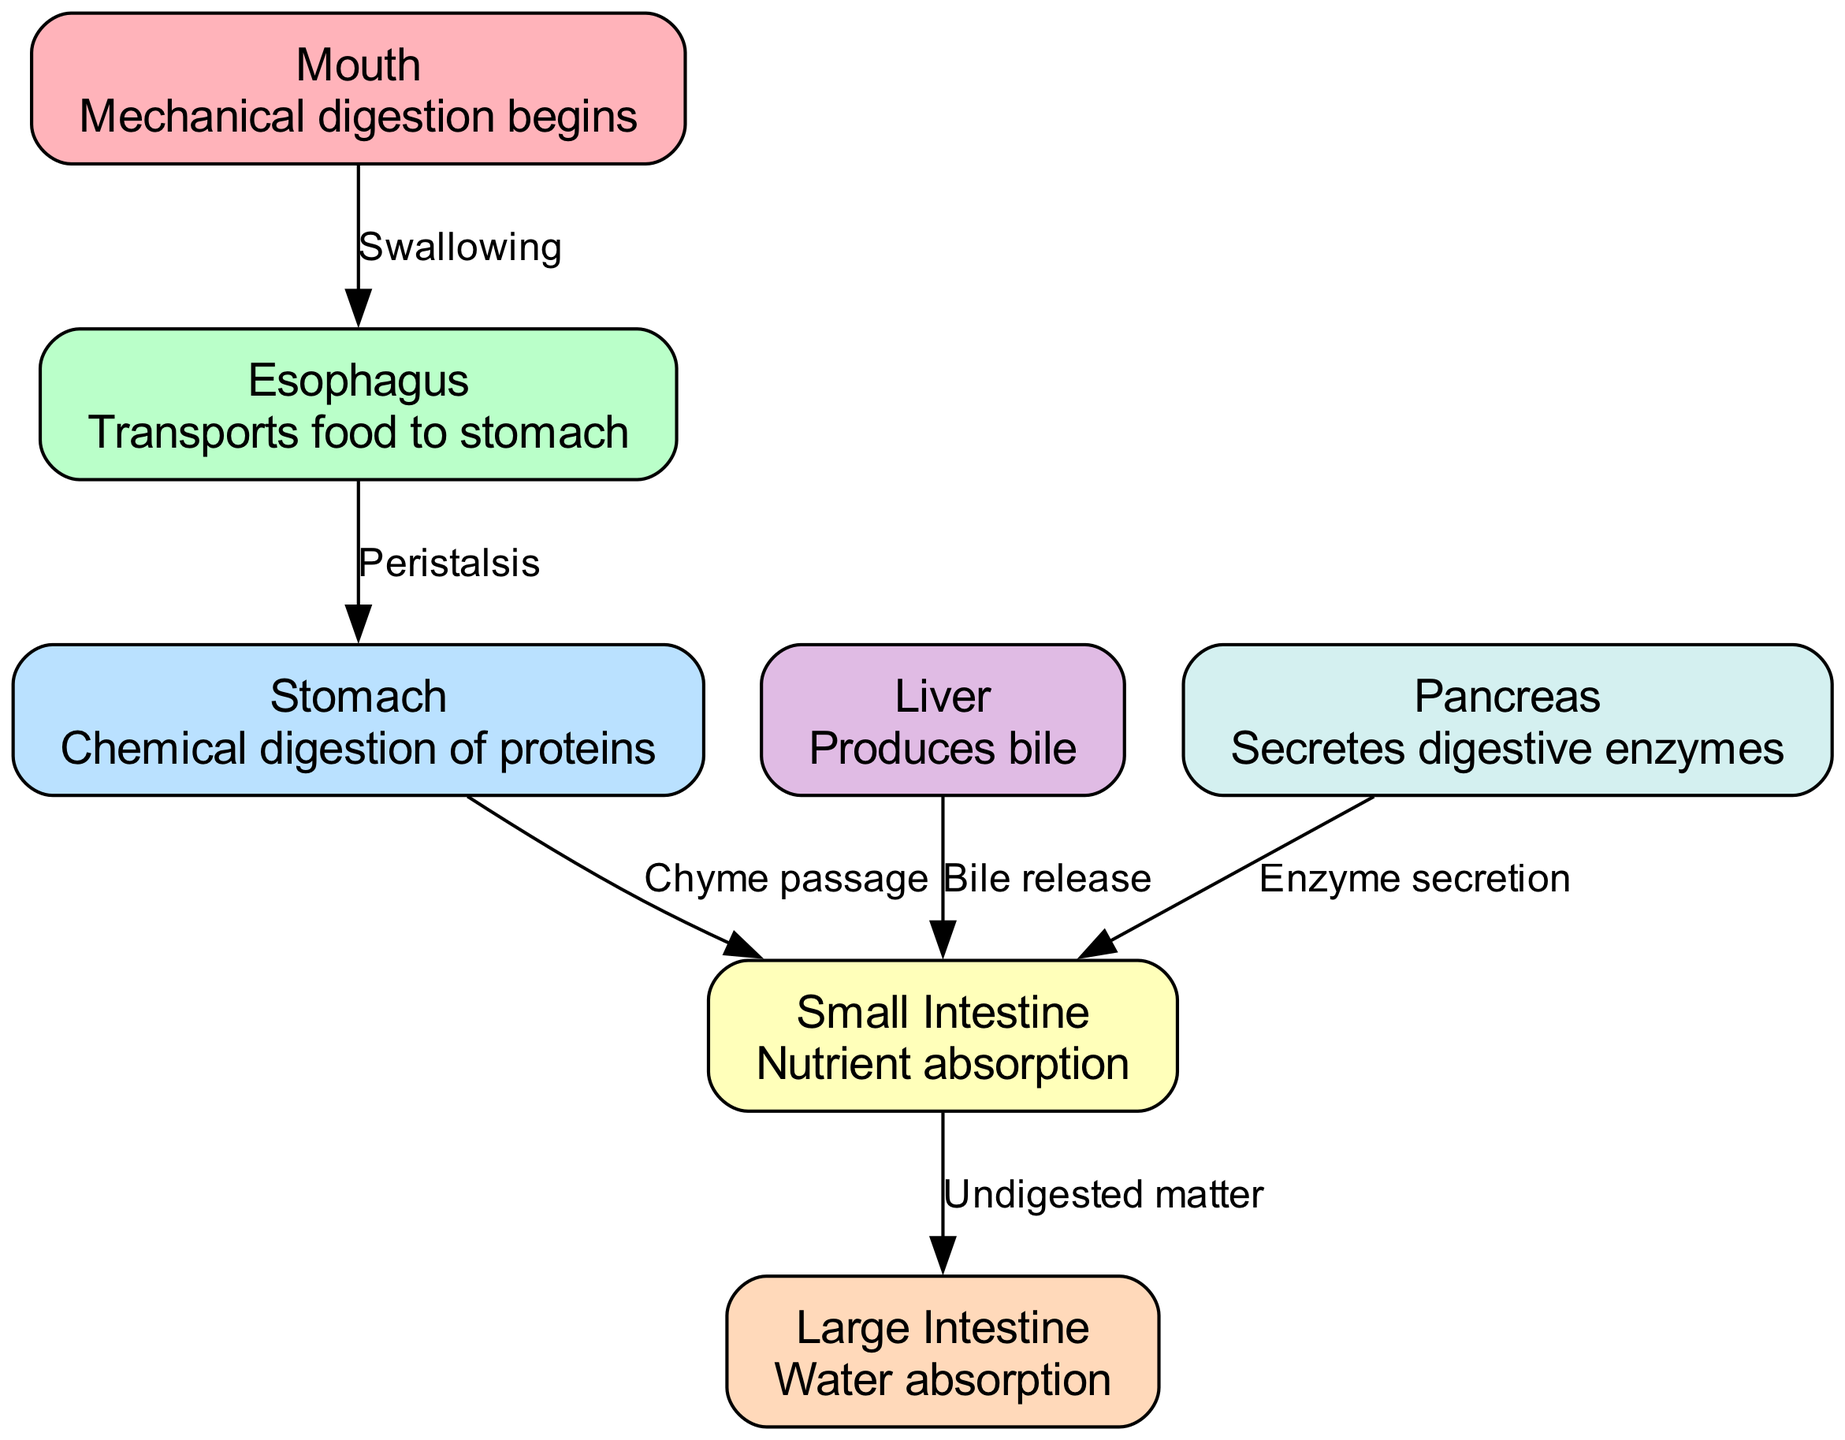What is the first organ in the digestive system? The diagram lists the organs and their functions, starting with the mouth. Since it is the first one listed and is the primary entry point for food ingestion, this confirms it as the first organ.
Answer: Mouth How many organs are represented in the diagram? By counting the nodes provided in the data, there are a total of six organs depicted in the diagram: mouth, esophagus, stomach, small intestine, large intestine, liver, and pancreas.
Answer: Six What process occurs in the stomach? The stomach is specifically labeled with the description indicating that it is responsible for the chemical digestion of proteins, as noted in the diagram.
Answer: Chemical digestion of proteins Which organ is responsible for nutrient absorption? The small intestine is labeled in the diagram with the description detailing its function as the site for nutrient absorption, thus making it the correct answer.
Answer: Small intestine What transport method is indicated between the mouth and esophagus? The edge between the mouth and esophagus is labeled with "Swallowing," which describes the specific transport method of food from the mouth to the esophagus.
Answer: Swallowing What is released by the liver into the small intestine? The diagram shows an edge from the liver to the small intestine labeled "Bile release." Therefore, this indicates that bile is the substance released by the liver.
Answer: Bile How does food move from the esophagus to the stomach? The diagram indicates that "Peristalsis" is the method by which food is transported from the esophagus to the stomach, as represented by the edge connecting these two organs.
Answer: Peristalsis Which organ secretes digestive enzymes? The pancreas is identified in the diagram as the organ responsible for secreting digestive enzymes, as indicated by its description in the node.
Answer: Pancreas What type of matter is passed from the small intestine to the large intestine? The diagram states that the small intestine passes "Undigested matter" to the large intestine, making this the specific type of matter transferred.
Answer: Undigested matter 